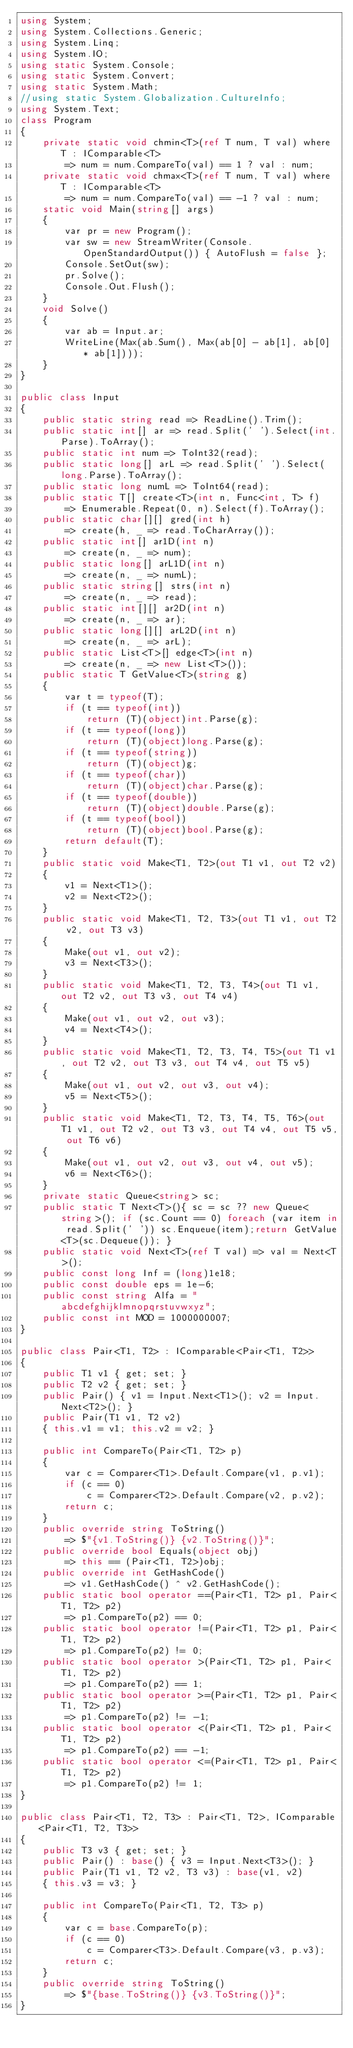Convert code to text. <code><loc_0><loc_0><loc_500><loc_500><_C#_>using System;
using System.Collections.Generic;
using System.Linq;
using System.IO;
using static System.Console;
using static System.Convert;
using static System.Math;
//using static System.Globalization.CultureInfo;
using System.Text;
class Program
{
    private static void chmin<T>(ref T num, T val) where T : IComparable<T>
        => num = num.CompareTo(val) == 1 ? val : num;
    private static void chmax<T>(ref T num, T val) where T : IComparable<T>
        => num = num.CompareTo(val) == -1 ? val : num;
    static void Main(string[] args)
    {
        var pr = new Program();
        var sw = new StreamWriter(Console.OpenStandardOutput()) { AutoFlush = false };
        Console.SetOut(sw);
        pr.Solve();
        Console.Out.Flush();
    }
    void Solve()
    {
        var ab = Input.ar;
        WriteLine(Max(ab.Sum(), Max(ab[0] - ab[1], ab[0] * ab[1])));
    }
}

public class Input
{
    public static string read => ReadLine().Trim();
    public static int[] ar => read.Split(' ').Select(int.Parse).ToArray();
    public static int num => ToInt32(read);
    public static long[] arL => read.Split(' ').Select(long.Parse).ToArray();
    public static long numL => ToInt64(read);
    public static T[] create<T>(int n, Func<int, T> f)
        => Enumerable.Repeat(0, n).Select(f).ToArray();
    public static char[][] gred(int h)
        => create(h, _ => read.ToCharArray());
    public static int[] ar1D(int n)
        => create(n, _ => num);
    public static long[] arL1D(int n)
        => create(n, _ => numL);
    public static string[] strs(int n)
        => create(n, _ => read);
    public static int[][] ar2D(int n)
        => create(n, _ => ar);
    public static long[][] arL2D(int n)
        => create(n, _ => arL);
    public static List<T>[] edge<T>(int n)
        => create(n, _ => new List<T>());
    public static T GetValue<T>(string g)
    {
        var t = typeof(T);
        if (t == typeof(int))
            return (T)(object)int.Parse(g);
        if (t == typeof(long))
            return (T)(object)long.Parse(g);
        if (t == typeof(string))
            return (T)(object)g;
        if (t == typeof(char))
            return (T)(object)char.Parse(g);
        if (t == typeof(double))
            return (T)(object)double.Parse(g);
        if (t == typeof(bool))
            return (T)(object)bool.Parse(g);
        return default(T);
    }
    public static void Make<T1, T2>(out T1 v1, out T2 v2)
    {
        v1 = Next<T1>();
        v2 = Next<T2>();
    }
    public static void Make<T1, T2, T3>(out T1 v1, out T2 v2, out T3 v3)
    {
        Make(out v1, out v2);
        v3 = Next<T3>();
    }
    public static void Make<T1, T2, T3, T4>(out T1 v1, out T2 v2, out T3 v3, out T4 v4)
    {
        Make(out v1, out v2, out v3);
        v4 = Next<T4>();
    }
    public static void Make<T1, T2, T3, T4, T5>(out T1 v1, out T2 v2, out T3 v3, out T4 v4, out T5 v5)
    {
        Make(out v1, out v2, out v3, out v4);
        v5 = Next<T5>();
    }
    public static void Make<T1, T2, T3, T4, T5, T6>(out T1 v1, out T2 v2, out T3 v3, out T4 v4, out T5 v5, out T6 v6)
    {
        Make(out v1, out v2, out v3, out v4, out v5);
        v6 = Next<T6>();
    }
    private static Queue<string> sc;
    public static T Next<T>(){ sc = sc ?? new Queue<string>(); if (sc.Count == 0) foreach (var item in read.Split(' ')) sc.Enqueue(item);return GetValue<T>(sc.Dequeue()); }
    public static void Next<T>(ref T val) => val = Next<T>(); 
    public const long Inf = (long)1e18;
    public const double eps = 1e-6;
    public const string Alfa = "abcdefghijklmnopqrstuvwxyz";
    public const int MOD = 1000000007;
}

public class Pair<T1, T2> : IComparable<Pair<T1, T2>>
{
    public T1 v1 { get; set; }
    public T2 v2 { get; set; }
    public Pair() { v1 = Input.Next<T1>(); v2 = Input.Next<T2>(); }
    public Pair(T1 v1, T2 v2)
    { this.v1 = v1; this.v2 = v2; }

    public int CompareTo(Pair<T1, T2> p)
    {
        var c = Comparer<T1>.Default.Compare(v1, p.v1);
        if (c == 0)
            c = Comparer<T2>.Default.Compare(v2, p.v2);
        return c;
    }
    public override string ToString()
        => $"{v1.ToString()} {v2.ToString()}";
    public override bool Equals(object obj)
        => this == (Pair<T1, T2>)obj;
    public override int GetHashCode()
        => v1.GetHashCode() ^ v2.GetHashCode();
    public static bool operator ==(Pair<T1, T2> p1, Pair<T1, T2> p2)
        => p1.CompareTo(p2) == 0;
    public static bool operator !=(Pair<T1, T2> p1, Pair<T1, T2> p2)
        => p1.CompareTo(p2) != 0;
    public static bool operator >(Pair<T1, T2> p1, Pair<T1, T2> p2)
        => p1.CompareTo(p2) == 1;
    public static bool operator >=(Pair<T1, T2> p1, Pair<T1, T2> p2)
        => p1.CompareTo(p2) != -1;
    public static bool operator <(Pair<T1, T2> p1, Pair<T1, T2> p2)
        => p1.CompareTo(p2) == -1;
    public static bool operator <=(Pair<T1, T2> p1, Pair<T1, T2> p2)
        => p1.CompareTo(p2) != 1;
}

public class Pair<T1, T2, T3> : Pair<T1, T2>, IComparable<Pair<T1, T2, T3>>
{
    public T3 v3 { get; set; }
    public Pair() : base() { v3 = Input.Next<T3>(); }
    public Pair(T1 v1, T2 v2, T3 v3) : base(v1, v2)
    { this.v3 = v3; }

    public int CompareTo(Pair<T1, T2, T3> p)
    {
        var c = base.CompareTo(p);
        if (c == 0)
            c = Comparer<T3>.Default.Compare(v3, p.v3);
        return c;
    }
    public override string ToString()
        => $"{base.ToString()} {v3.ToString()}";
}
</code> 